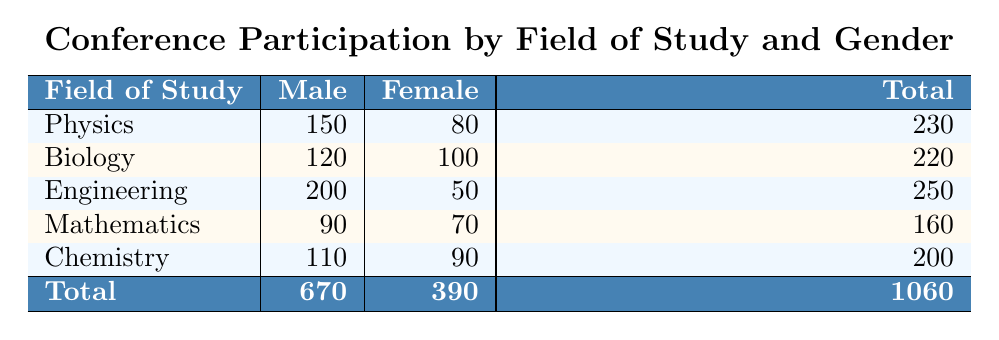What is the total number of male participants in all fields? To find the total number of male participants, we sum the number of male participants from each field: 150 (Physics) + 120 (Biology) + 200 (Engineering) + 90 (Mathematics) + 110 (Chemistry) = 670.
Answer: 670 Which field has the highest number of female participants? From the table, the female participants are as follows: 80 (Physics), 100 (Biology), 50 (Engineering), 70 (Mathematics), and 90 (Chemistry). The highest number is 100, which is from the Biology field.
Answer: Biology What is the difference between the number of male and female participants in Engineering? For Engineering, there are 200 male participants and 50 female participants. The difference is calculated as 200 - 50 = 150.
Answer: 150 Is there a field of study where the number of male participants is greater than the number of female participants? Yes, in multiple fields, male participants outnumber female participants, notably in Physics (150 vs. 80) and Engineering (200 vs. 50).
Answer: Yes What is the average number of participants across all fields? To find the average, we first find the total number of participants. The total is 1060 as given in the table. There are 5 fields, so the average is 1060 / 5 = 212.
Answer: 212 Which field has the lowest total number of participants? We calculate the total participants for each field: Physics (230), Biology (220), Engineering (250), Mathematics (160), Chemistry (200). The lowest is 160, which corresponds to Mathematics.
Answer: Mathematics Are there more male participants or female participants across all fields combined? The total number of male participants is 670, while the total number of female participants is 390. Since 670 is greater than 390, there are indeed more male participants.
Answer: Yes What percentage of total participants are female? The total number of participants is 1060, and there are 390 female participants. To find the percentage, we calculate (390 / 1060) * 100, which gives approximately 36.79%.
Answer: 36.79% Which field has the highest total number of participants? By reviewing the total participants for each field: Physics (230), Biology (220), Engineering (250), Mathematics (160), Chemistry (200), the highest total is 250, from Engineering.
Answer: Engineering 